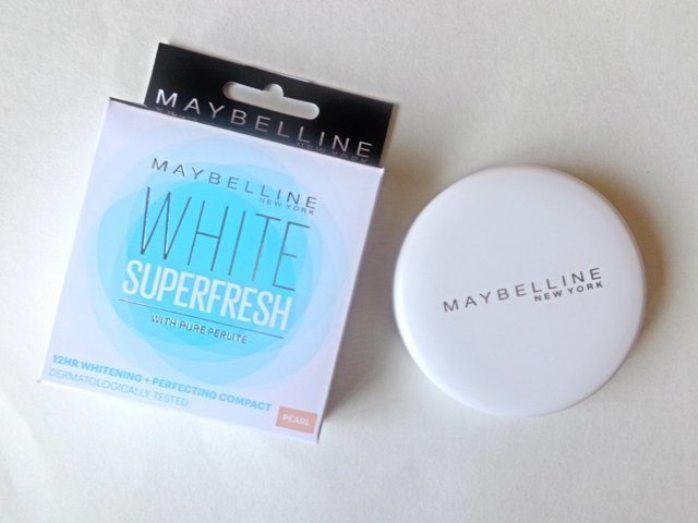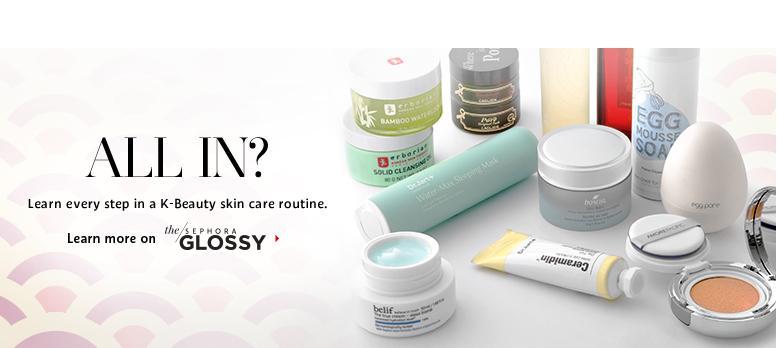The first image is the image on the left, the second image is the image on the right. For the images displayed, is the sentence "One image shows no more than three items, which are laid flat on a surface, and the other image includes multiple products displayed standing upright." factually correct? Answer yes or no. Yes. 